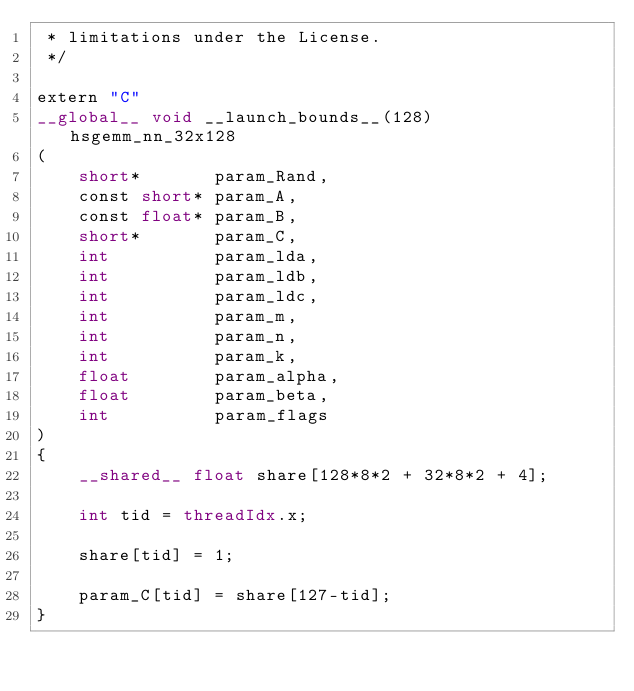<code> <loc_0><loc_0><loc_500><loc_500><_Cuda_> * limitations under the License.
 */

extern "C"
__global__ void __launch_bounds__(128) hsgemm_nn_32x128
(
    short*       param_Rand,
    const short* param_A,
    const float* param_B,
    short*       param_C,
    int          param_lda,  
    int          param_ldb,  
    int          param_ldc,
    int          param_m,
    int          param_n,
    int          param_k,
    float        param_alpha,
    float        param_beta,
    int          param_flags
)
{
    __shared__ float share[128*8*2 + 32*8*2 + 4];

    int tid = threadIdx.x;

    share[tid] = 1;

    param_C[tid] = share[127-tid];
}
</code> 